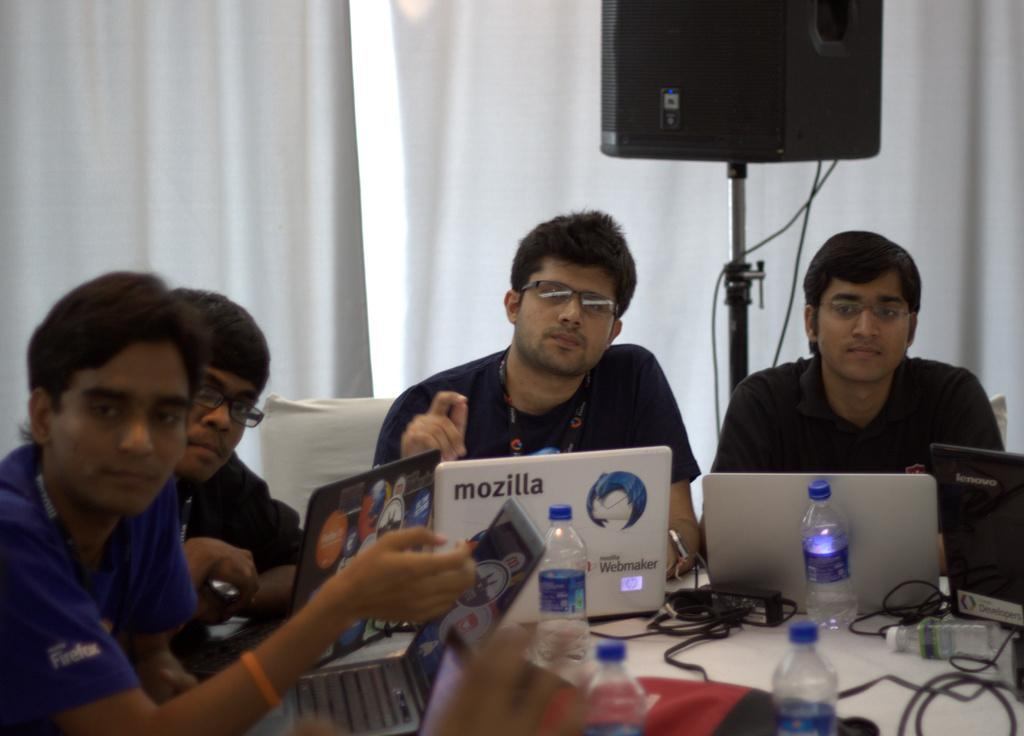How many people are in the image? There are four persons in the image. What are the persons wearing? The persons are wearing clothes. Where are the persons sitting? The persons are sitting in front of a table. What items can be seen on the table? The table contains bottles and a laptop. What additional object is present in the image? There is a speaker in the top right of the image. What type of lace can be seen on the clothing of the persons in the image? There is no lace visible on the clothing of the persons in the image. How many clovers are present on the table in the image? There are no clovers present on the table in the image. 